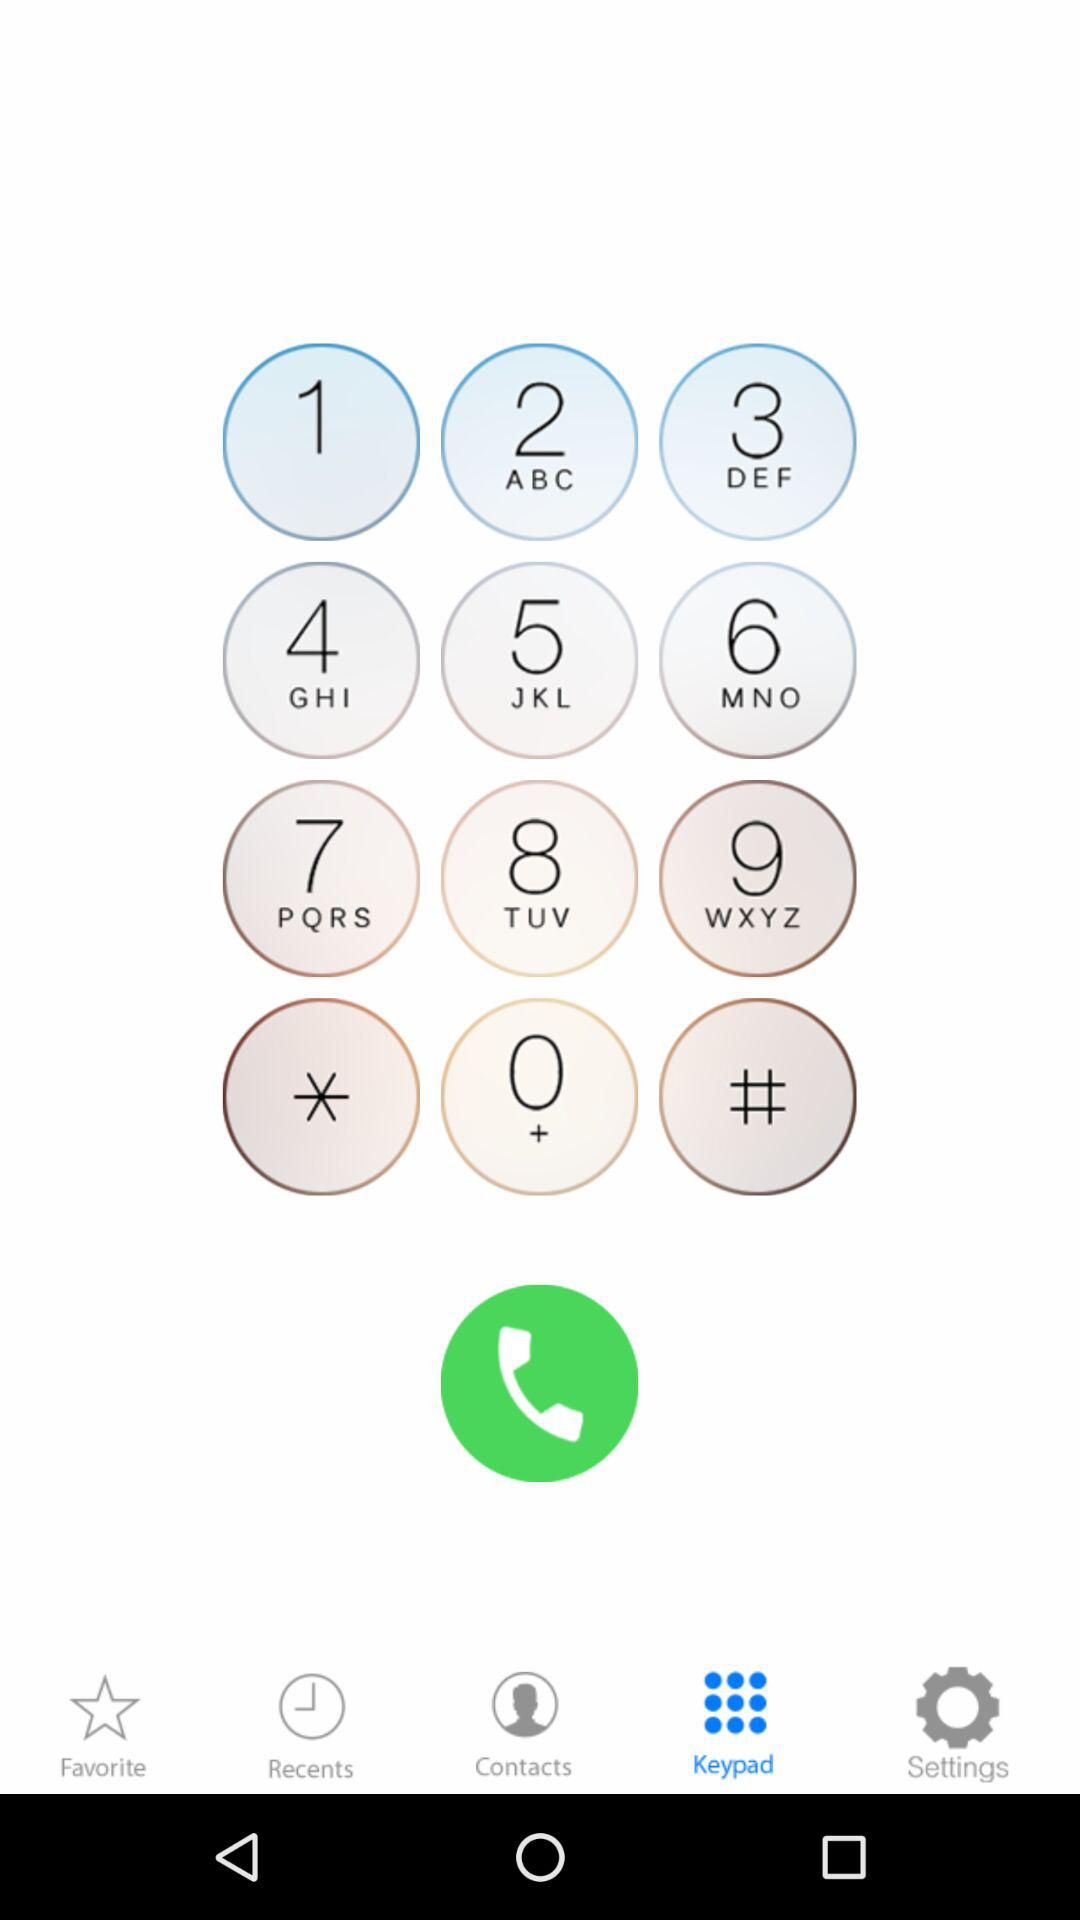Which tab is selected? The selected tab is "Keypad". 